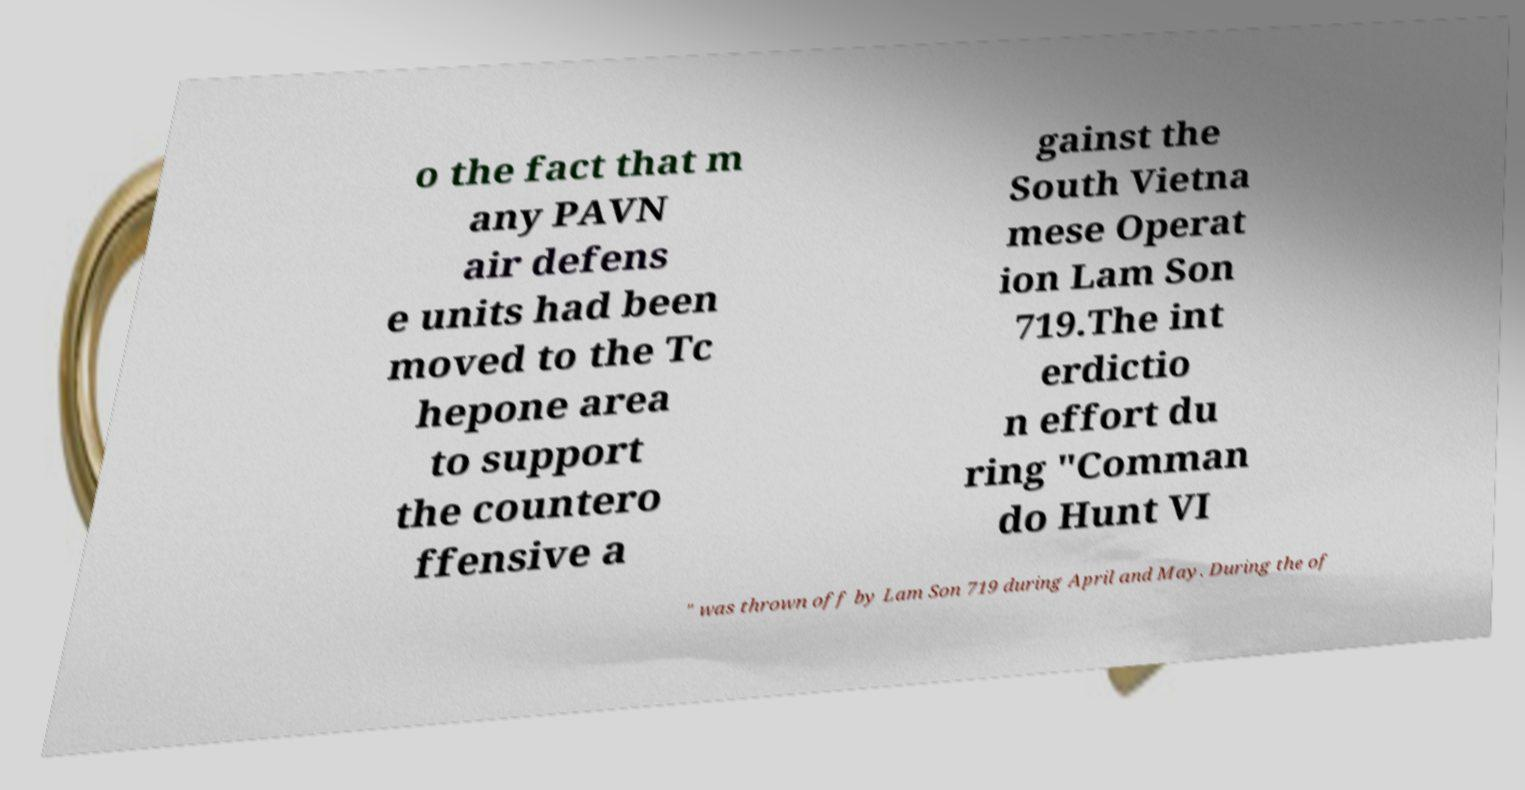Could you extract and type out the text from this image? o the fact that m any PAVN air defens e units had been moved to the Tc hepone area to support the countero ffensive a gainst the South Vietna mese Operat ion Lam Son 719.The int erdictio n effort du ring "Comman do Hunt VI " was thrown off by Lam Son 719 during April and May. During the of 